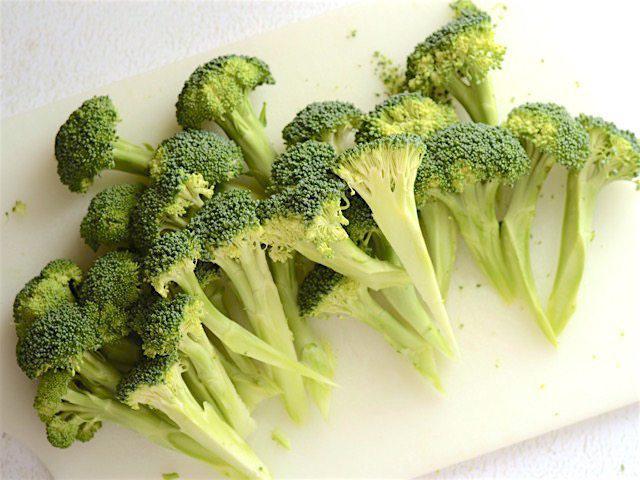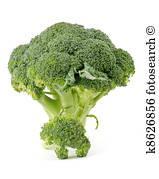The first image is the image on the left, the second image is the image on the right. Evaluate the accuracy of this statement regarding the images: "An image shows a round dish that contains only broccoli.". Is it true? Answer yes or no. No. The first image is the image on the left, the second image is the image on the right. Assess this claim about the two images: "There are two veggies shown in the image on the left.". Correct or not? Answer yes or no. No. 